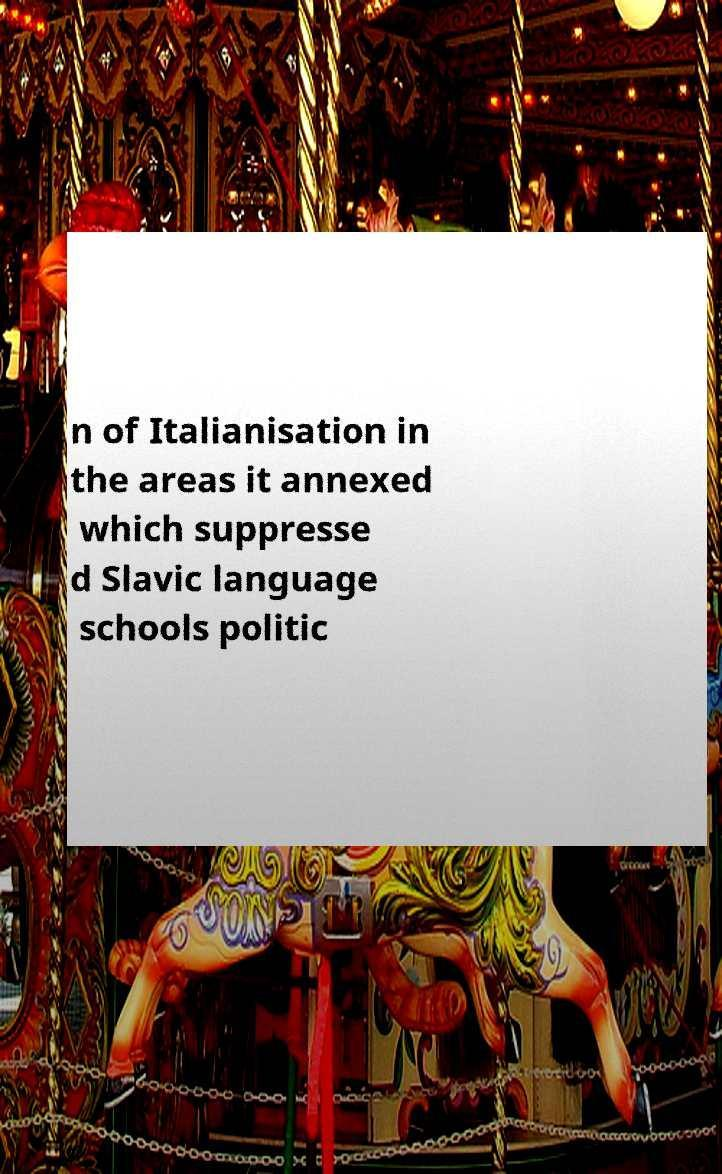Can you read and provide the text displayed in the image?This photo seems to have some interesting text. Can you extract and type it out for me? n of Italianisation in the areas it annexed which suppresse d Slavic language schools politic 